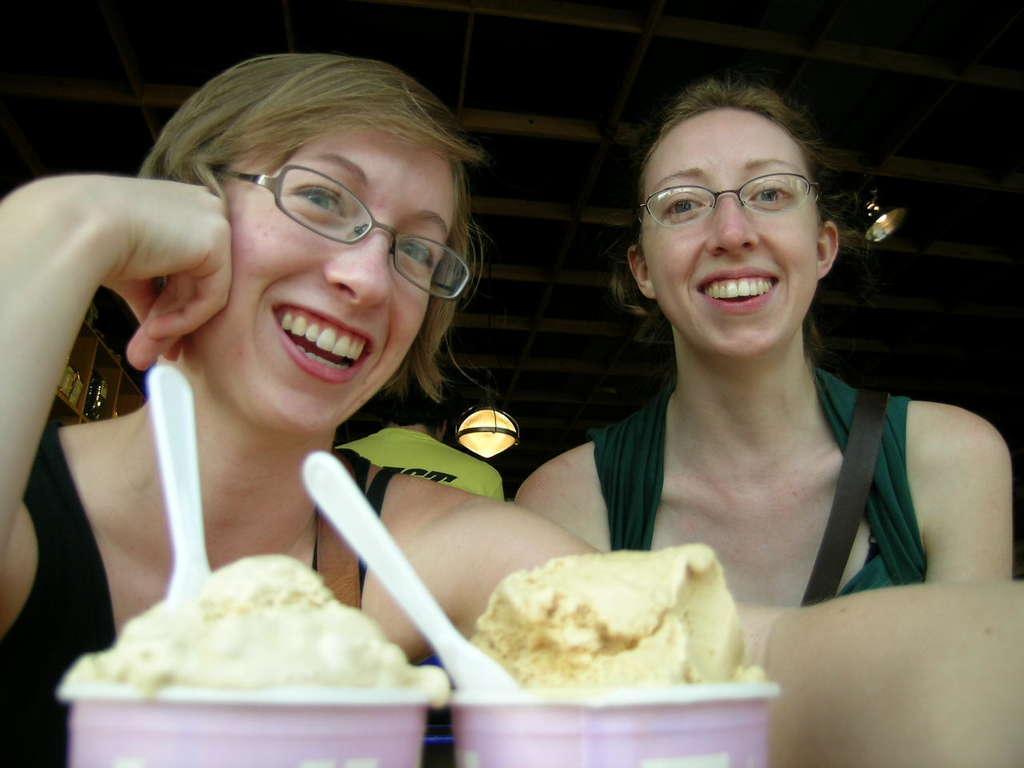Can you describe this image briefly? In this picture we can see two ladies are sitting and smiling and wearing spectacles. At the bottom of the image we can see the cups which contains ice-cream with spoons. In the background of the image we can see the lights, wall, shelves. In shelves we can see the bottles. At the top of the image we can see the roof. 